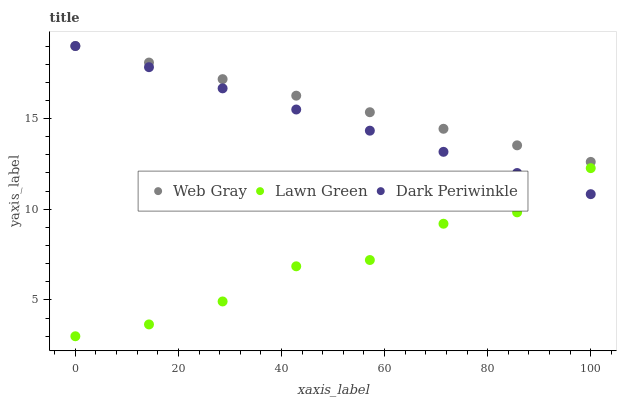Does Lawn Green have the minimum area under the curve?
Answer yes or no. Yes. Does Web Gray have the maximum area under the curve?
Answer yes or no. Yes. Does Dark Periwinkle have the minimum area under the curve?
Answer yes or no. No. Does Dark Periwinkle have the maximum area under the curve?
Answer yes or no. No. Is Dark Periwinkle the smoothest?
Answer yes or no. Yes. Is Lawn Green the roughest?
Answer yes or no. Yes. Is Web Gray the smoothest?
Answer yes or no. No. Is Web Gray the roughest?
Answer yes or no. No. Does Lawn Green have the lowest value?
Answer yes or no. Yes. Does Dark Periwinkle have the lowest value?
Answer yes or no. No. Does Dark Periwinkle have the highest value?
Answer yes or no. Yes. Is Lawn Green less than Web Gray?
Answer yes or no. Yes. Is Web Gray greater than Lawn Green?
Answer yes or no. Yes. Does Dark Periwinkle intersect Lawn Green?
Answer yes or no. Yes. Is Dark Periwinkle less than Lawn Green?
Answer yes or no. No. Is Dark Periwinkle greater than Lawn Green?
Answer yes or no. No. Does Lawn Green intersect Web Gray?
Answer yes or no. No. 